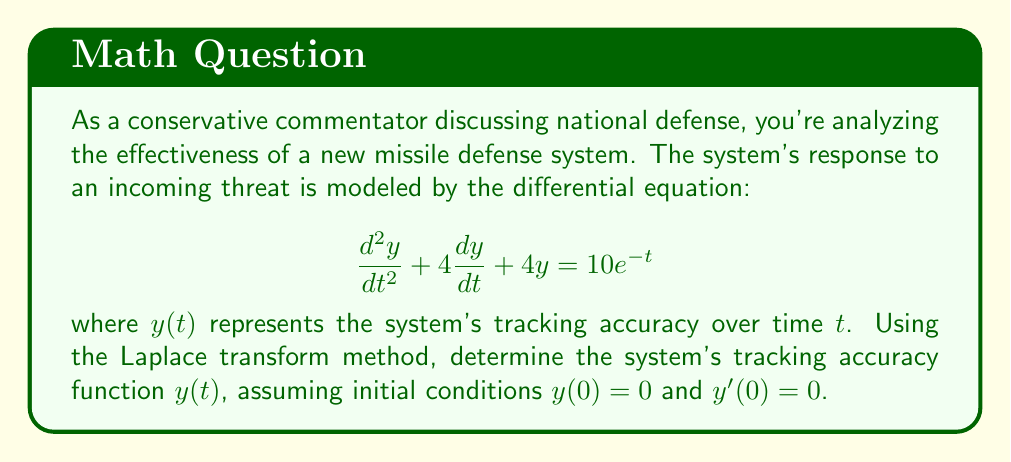Show me your answer to this math problem. To solve this problem using Laplace transforms, we'll follow these steps:

1) Take the Laplace transform of both sides of the differential equation:

   $\mathcal{L}\{\frac{d^2y}{dt^2} + 4\frac{dy}{dt} + 4y\} = \mathcal{L}\{10e^{-t}\}$

2) Apply Laplace transform properties:

   $s^2Y(s) - sy(0) - y'(0) + 4[sY(s) - y(0)] + 4Y(s) = \frac{10}{s+1}$

3) Substitute the initial conditions $y(0) = 0$ and $y'(0) = 0$:

   $s^2Y(s) + 4sY(s) + 4Y(s) = \frac{10}{s+1}$

4) Factor out $Y(s)$:

   $Y(s)(s^2 + 4s + 4) = \frac{10}{s+1}$

5) Solve for $Y(s)$:

   $Y(s) = \frac{10}{(s^2 + 4s + 4)(s+1)} = \frac{10}{(s+2)^2(s+1)}$

6) Perform partial fraction decomposition:

   $Y(s) = \frac{A}{s+1} + \frac{B}{s+2} + \frac{C}{(s+2)^2}$

   Solving for $A$, $B$, and $C$:
   $A = \frac{10}{1} = 10$
   $B = -\frac{20}{1} = -20$
   $C = \frac{10}{1} = 10$

   So, $Y(s) = \frac{10}{s+1} - \frac{20}{s+2} + \frac{10}{(s+2)^2}$

7) Take the inverse Laplace transform:

   $y(t) = 10e^{-t} - 20e^{-2t} + 10te^{-2t}$

This is the tracking accuracy function of the missile defense system over time.
Answer: $y(t) = 10e^{-t} - 20e^{-2t} + 10te^{-2t}$ 